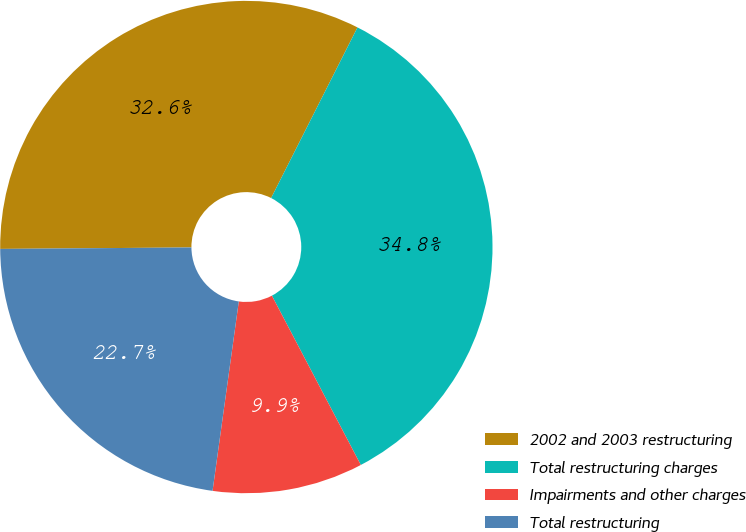Convert chart. <chart><loc_0><loc_0><loc_500><loc_500><pie_chart><fcel>2002 and 2003 restructuring<fcel>Total restructuring charges<fcel>Impairments and other charges<fcel>Total restructuring<nl><fcel>32.58%<fcel>34.85%<fcel>9.89%<fcel>22.69%<nl></chart> 